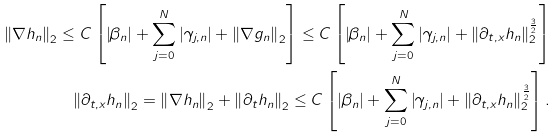<formula> <loc_0><loc_0><loc_500><loc_500>\left \| \nabla h _ { n } \right \| _ { 2 } \leq C \left [ \left | \beta _ { n } \right | + \sum _ { j = 0 } ^ { N } \left | \gamma _ { j , n } \right | + \left \| \nabla g _ { n } \right \| _ { 2 } \right ] \leq C \left [ \left | \beta _ { n } \right | + \sum _ { j = 0 } ^ { N } \left | \gamma _ { j , n } \right | + \| \partial _ { t , x } h _ { n } \| _ { 2 } ^ { \frac { 3 } { 2 } } \right ] \\ \left \| \partial _ { t , x } h _ { n } \right \| _ { 2 } = \left \| \nabla h _ { n } \right \| _ { 2 } + \left \| \partial _ { t } h _ { n } \right \| _ { 2 } \leq C \left [ \left | \beta _ { n } \right | + \sum _ { j = 0 } ^ { N } \left | \gamma _ { j , n } \right | + \| \partial _ { t , x } h _ { n } \| _ { 2 } ^ { \frac { 3 } { 2 } } \right ] .</formula> 